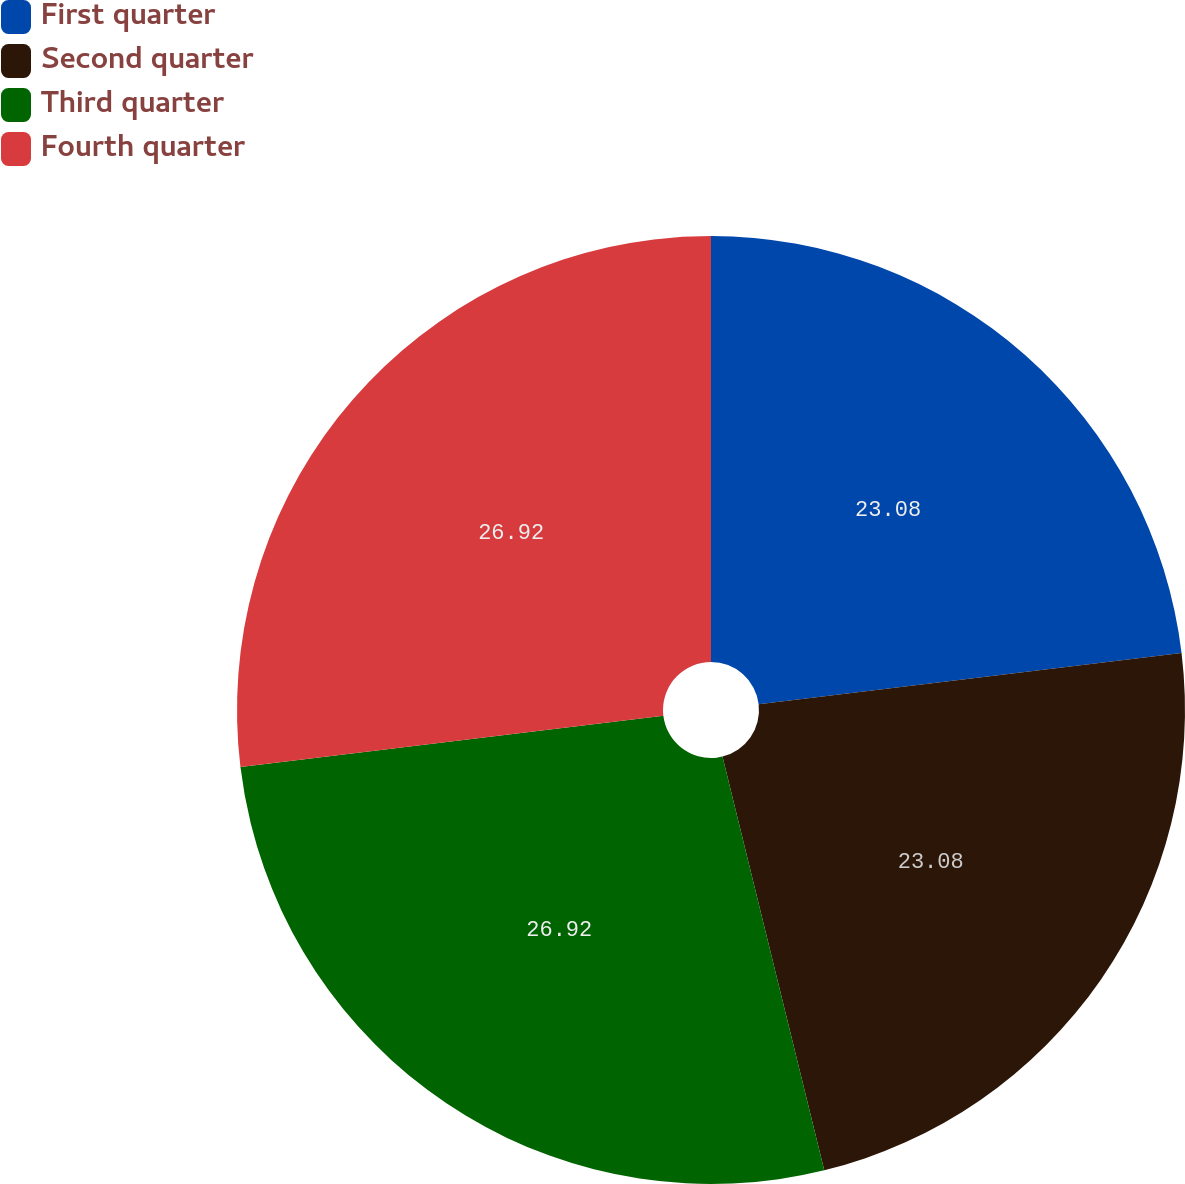Convert chart. <chart><loc_0><loc_0><loc_500><loc_500><pie_chart><fcel>First quarter<fcel>Second quarter<fcel>Third quarter<fcel>Fourth quarter<nl><fcel>23.08%<fcel>23.08%<fcel>26.92%<fcel>26.92%<nl></chart> 